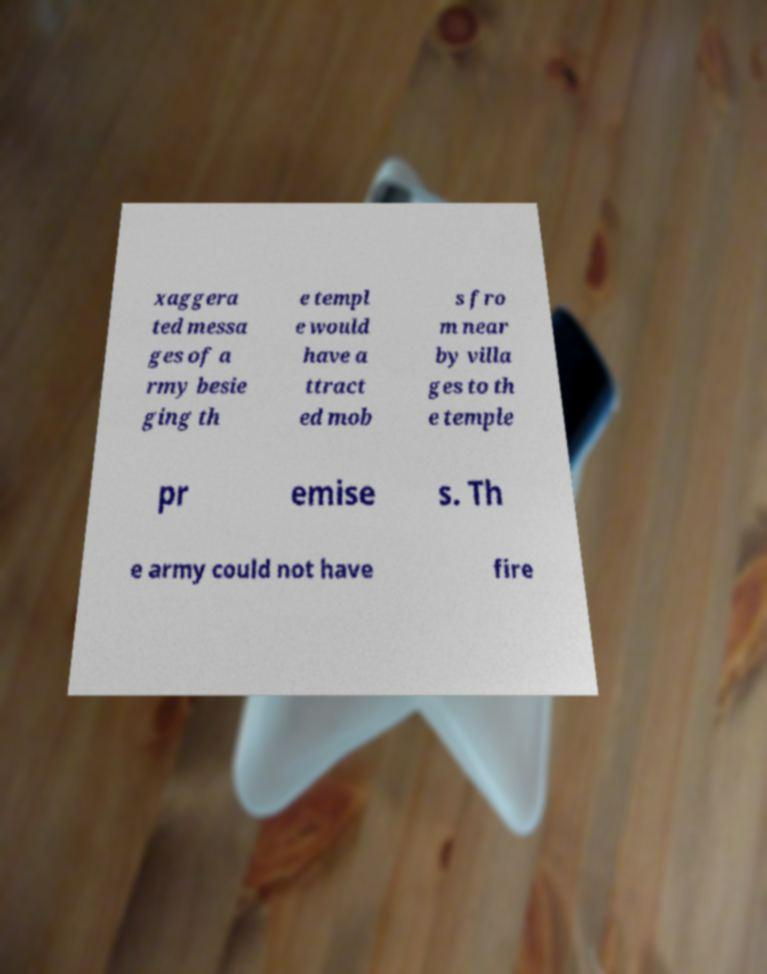Please identify and transcribe the text found in this image. xaggera ted messa ges of a rmy besie ging th e templ e would have a ttract ed mob s fro m near by villa ges to th e temple pr emise s. Th e army could not have fire 